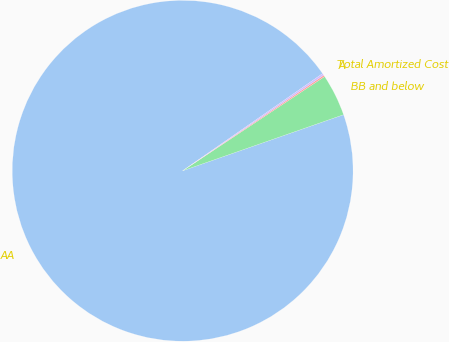Convert chart. <chart><loc_0><loc_0><loc_500><loc_500><pie_chart><fcel>AA<fcel>BB and below<fcel>A<fcel>Total Amortized Cost<nl><fcel>95.67%<fcel>3.99%<fcel>0.15%<fcel>0.18%<nl></chart> 